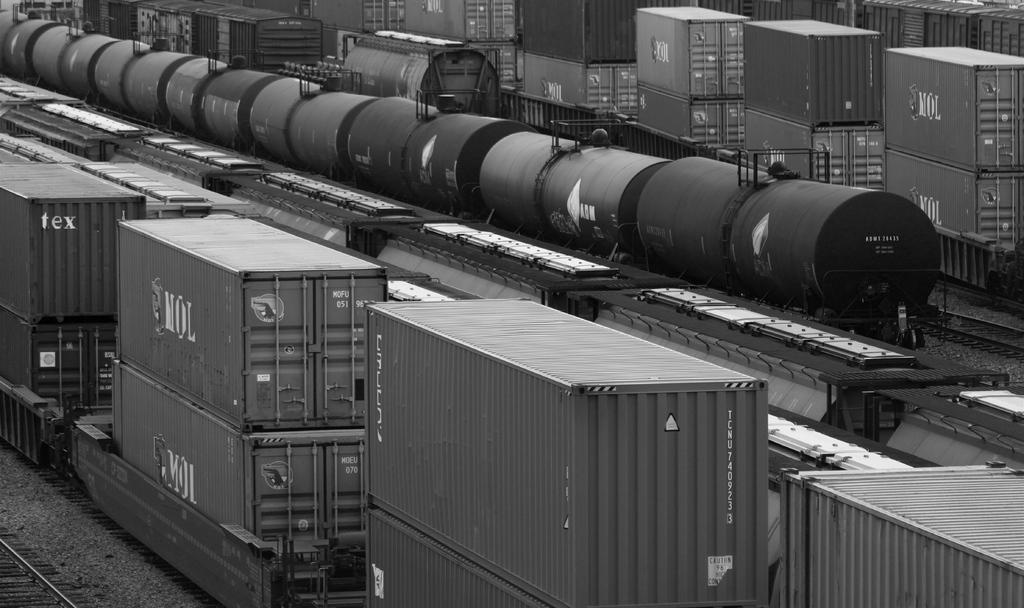What is the color scheme of the image? The image is black and white. What type of objects can be seen in the image? There are containers and a train in the image. What is the train situated on in the image? The train is situated on a railway track in the image. Are there any other objects present in the image? Yes, there are other objects in the image. Where is the railway track located in the image? The railway track is on the left side bottom of the image. What type of scarf is draped over the train in the image? There is no scarf present in the image; it is a black and white image featuring a train on a railway track. What type of brass material can be seen on the containers in the image? There is no brass material mentioned or visible in the image; the containers are not described in detail. 